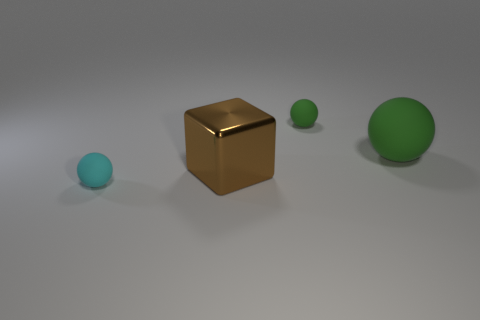How many green spheres must be subtracted to get 1 green spheres? 1 Subtract all cubes. How many objects are left? 3 Subtract 1 cubes. How many cubes are left? 0 Subtract all purple spheres. Subtract all yellow blocks. How many spheres are left? 3 Subtract all red cylinders. How many cyan balls are left? 1 Subtract all big gray matte balls. Subtract all small matte things. How many objects are left? 2 Add 4 large cubes. How many large cubes are left? 5 Add 4 tiny spheres. How many tiny spheres exist? 6 Add 4 cyan matte balls. How many objects exist? 8 Subtract all green balls. How many balls are left? 1 